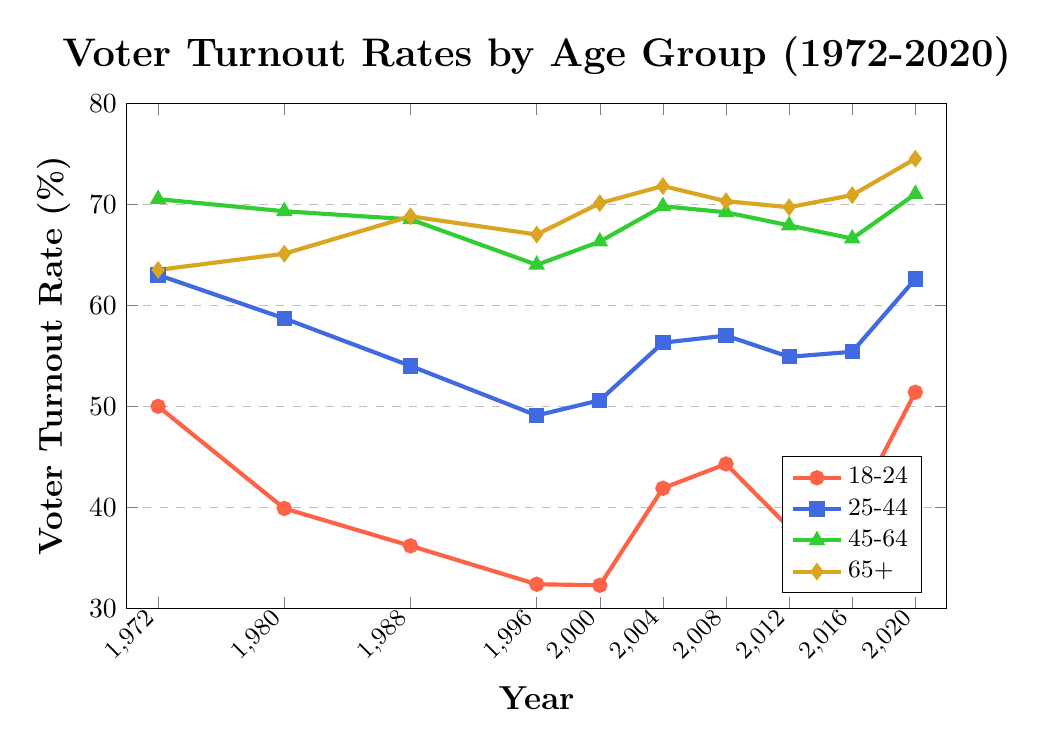What age group saw the most significant increase in voter turnout between 2016 and 2020? First, find the voter turnout rates for each age group in 2016 and 2020. Then, subtract the 2016 values from the 2020 values to determine the increases. 18-24: 51.4 - 39.4 = 12.0, 25-44: 62.6 - 55.4 = 7.2, 45-64: 71.0 - 66.6 = 4.4, 65+: 74.5 - 70.9 = 3.6. The 18-24 age group saw the most significant increase.
Answer: 18-24 Which age group consistently had the highest voter turnout rate in all years shown? Compare the voter turnout rates across all years for each age group. The 45-64 age group consistently had the highest voter turnout rate in all years.
Answer: 45-64 By how many percentage points did the voter turnout rate for the 18-24 age group change from 1972 to 2020? Subtract the voter turnout rate of 1972 from that of 2020 for the 18-24 age group: 51.4 (2020) - 50.0 (1972) = 1.4 percentage points.
Answer: 1.4 What is the overall trend in voter turnout rates for the 25-44 age group from 1972 to 2020? Observe the voter turnout rates for the 25-44 age group over the years. The trend shows a general decline from 1972 (63.0) to 1996 (49.1), followed by a fluctuating increase culminating in 62.6 in 2020.
Answer: Decline followed by fluctuating increase Which age group had the lowest voter turnout rate in 1988, and what was it? Identify the voter turnout rates for all age groups in 1988. The 18-24 age group had the lowest voter turnout rate at 36.2%.
Answer: 18-24, 36.2% Between which consecutive years did the voter turnout rate for the 45-64 age group decrease the most? Calculate the differences in voter turnout rates for the 45-64 age group between consecutive years: 1972-1980: 70.5 - 69.3 = 1.2, 1980-1988: 69.3 - 68.5 = 0.8, 1988-1996: 68.5 - 64.0 = 4.5, 1996-2000: 64.0 - 66.3 = -2.3, 2000-2004: 66.3 - 69.8 = -3.5, 2004-2008: 69.8 - 69.2 = 0.6, 2008-2012: 69.2 - 67.9 = 1.3, 2012-2016: 67.9 - 66.6 = 1.3, 2016-2020: 66.6 - 71.0 = -4.4. The greatest decrease is between 1988 and 1996 at 4.5 percentage points.
Answer: 1988 and 1996 What was the average voter turnout rate for the 65+ age group from 1972 to 2020? Sum the voter turnout rates for the 65+ age group from 1972 to 2020 and divide by the total number of years. (63.5 + 65.1 + 68.8 + 67.0 + 70.1 + 71.8 + 70.3 + 69.7 + 70.9 + 74.5) / 10 = 69.17%
Answer: 69.17% Who had a higher voter turnout rate in 1988, the 25-44 age group or the 65+ age group? By how much? Compare the voter turnout rates for the respective age groups in 1988. The 25-44 age group had 54.0%, and the 65+ age group had 68.8%. The 65+ age group had a higher rate by 68.8 - 54.0 = 14.8 percentage points.
Answer: 65+, 14.8% 